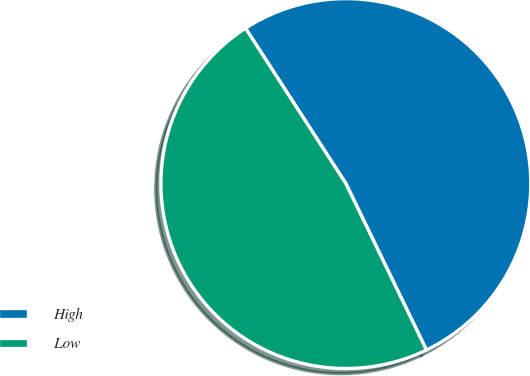<chart> <loc_0><loc_0><loc_500><loc_500><pie_chart><fcel>High<fcel>Low<nl><fcel>51.95%<fcel>48.05%<nl></chart> 